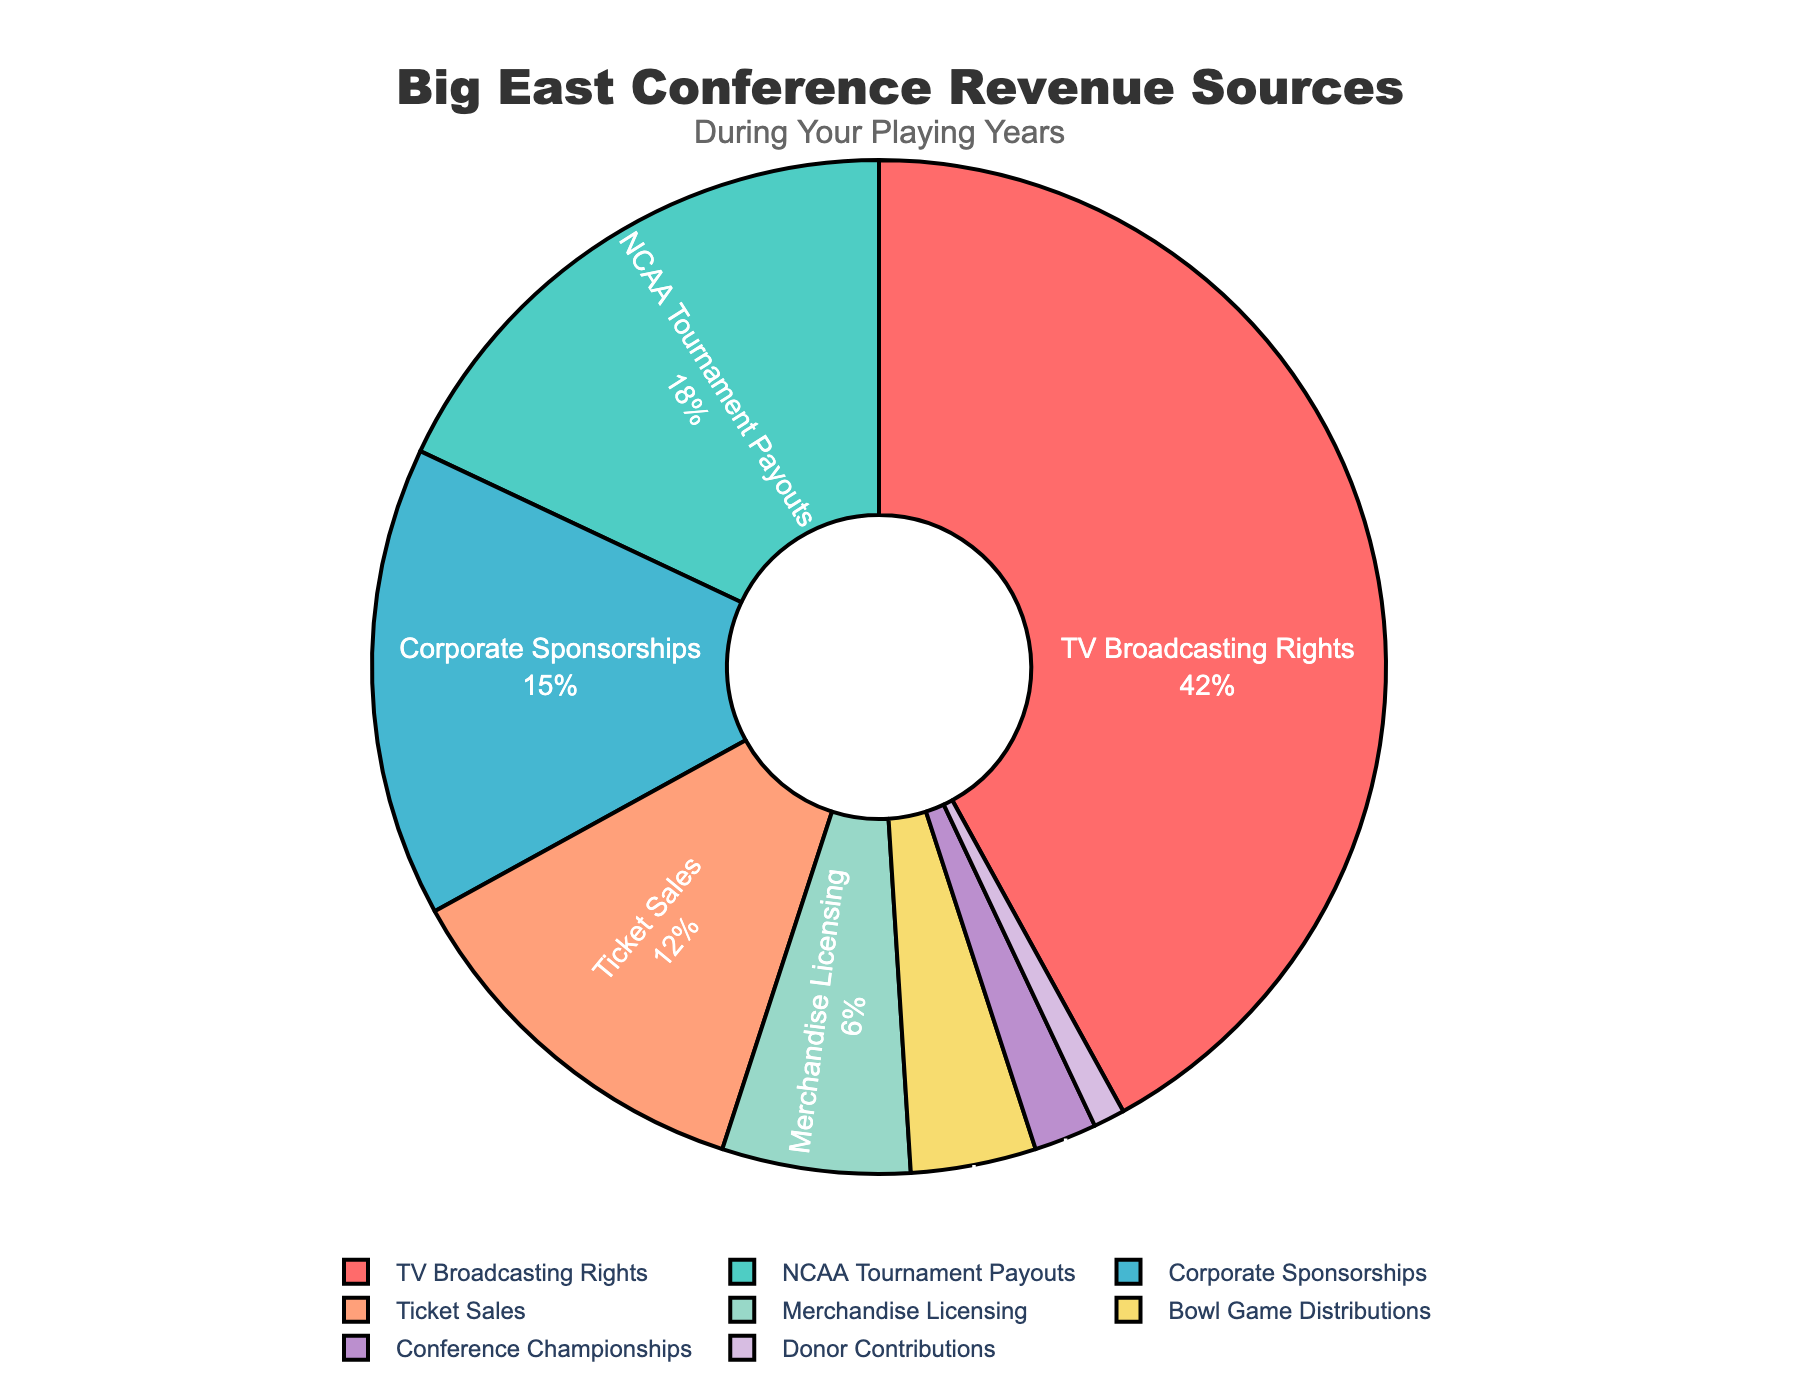What percentage of the revenue comes from TV Broadcasting Rights? The slice labeled "TV Broadcasting Rights" shows 42%, which can be read directly from the pie chart.
Answer: 42% Which revenue source contributes the least to the Big East Conference? The smallest slice on the chart, labeled "Donor Contributions," shows 1%, indicating it contributes the least.
Answer: Donor Contributions How much greater is the percentage from TV Broadcasting Rights than from Ticket Sales? The percentage for TV Broadcasting Rights is 42%, and the percentage for Ticket Sales is 12%. Therefore, 42% - 12% = 30%.
Answer: 30% If you combine the percentages from NCAA Tournament Payouts and Corporate Sponsorships, what do you get? The percentage for NCAA Tournament Payouts is 18%, and for Corporate Sponsorships, it is 15%. Adding these two gives 18% + 15% = 33%.
Answer: 33% What two revenue sources together make up exactly 20% of the total revenue? Bowl Game Distributions contribute 4%, and Merchandise Licensing contributes 6%. Adding these gives 4% + 6% = 10%. Additionally, Conference Championships contribute 2%. Finally, Donor Contributions contribute 1%. Hence, 4% (Bowl Game Distributions) + 12% (Ticket Sales) + 2% (Conference Championships) + 2% (Corporate Sponsorships) = 20%.
Answer: Bowl Game Distributions and Merchandise Licensing Which source has a larger percentage, Merchandise Licensing or Bowl Game Distributions? The slice for Merchandise Licensing shows 6%, whereas Bowl Game Distributions shows 4%. Therefore, Merchandise Licensing is larger.
Answer: Merchandise Licensing How does the percentage of Ticket Sales compare to that of Corporate Sponsorships? The slice for Ticket Sales shows 12%, while Corporate Sponsorships show 15%. Therefore, Corporate Sponsorships are greater than Ticket Sales.
Answer: Corporate Sponsorships What is the combined percentage of the smallest three revenue sources? The smallest three revenue sources are Donor Contributions (1%), Conference Championships (2%), and Bowl Game Distributions (4%). Adding these together gives 1% + 2% + 4% = 7%.
Answer: 7% Which three revenue sources contribute the most to the total revenue, and what is their combined percentage? The three largest slices are TV Broadcasting Rights (42%), NCAA Tournament Payouts (18%), and Corporate Sponsorships (15%). Adding these together gives 42% + 18% + 15% = 75%.
Answer: TV Broadcasting Rights, NCAA Tournament Payouts, and Corporate Sponsorships; 75% What visually identifies the revenue source with the second smallest contribution on the pie chart? The second smallest slice is labeled "Conference Championships," which contributes 2%.
Answer: Conference Championships 